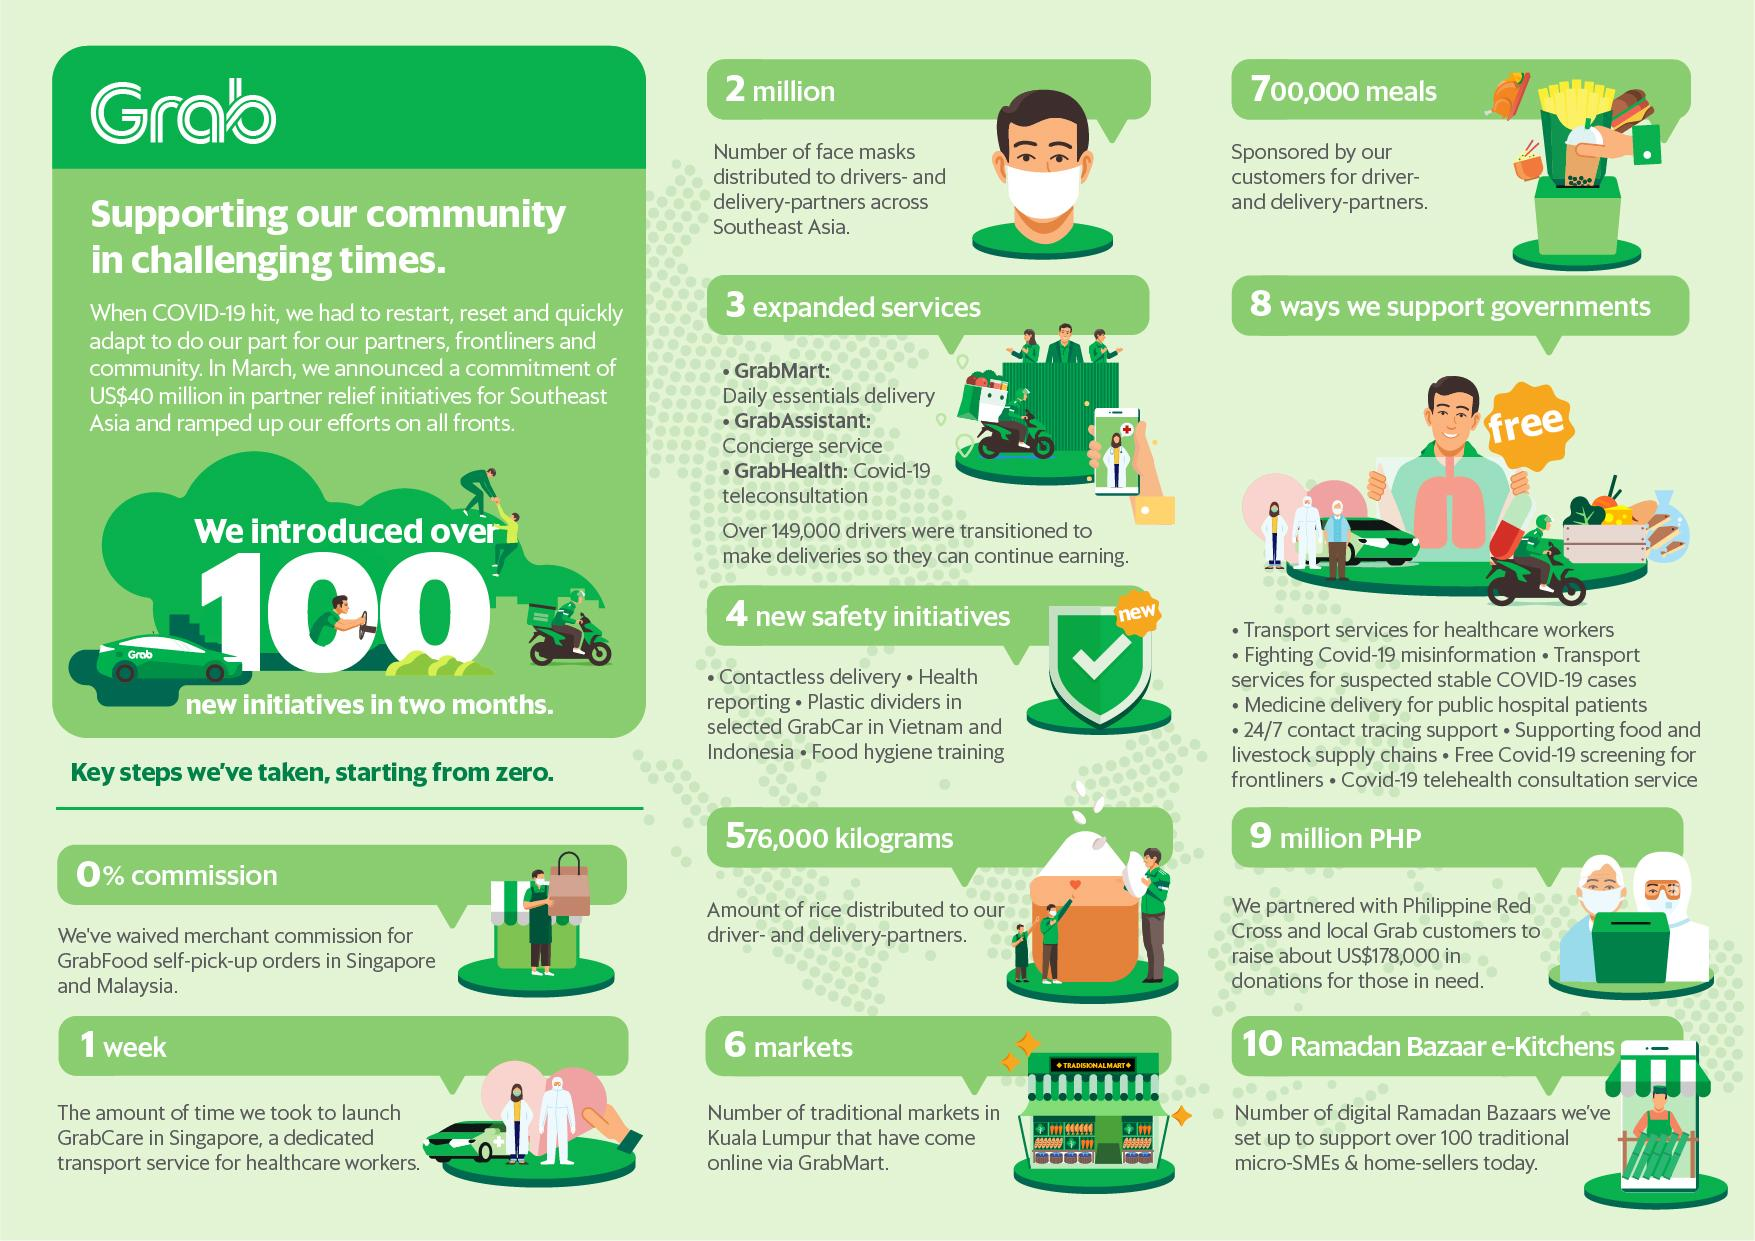Specify some key components in this picture. The Covid-19 tele-consultation service provided by Grab, known as GrabHealth, provides a platform for healthcare consultations through video calls. We have partnered with the Philippine Red Cross and local Grab customers to raise a total of 9 million PHP in donations. Grab customers sponsored a total of 700,000 meals for our driver and delivery partners. There are six traditional markets in Kuala Lumpur that have been launched on Grabmart. Grabfood has distributed a total of 2 million facemasks to drivers and delivery partners across Southeast Asia to help protect them from the COVID-19 pandemic. 